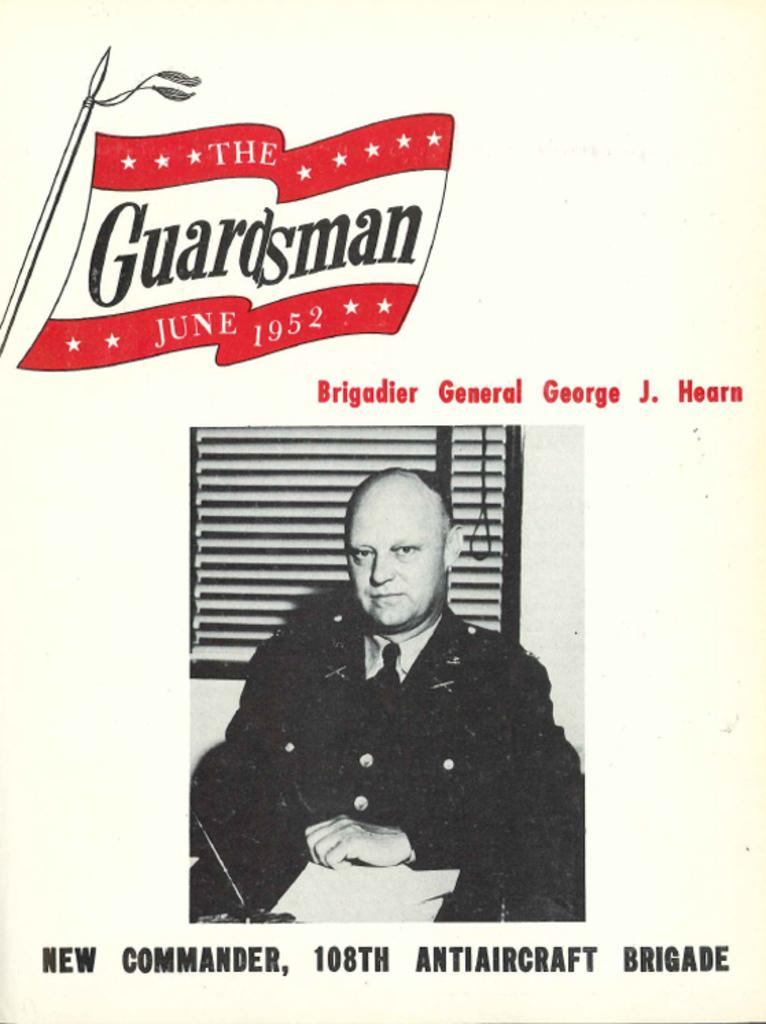What type of editing has been done to the image? The image is edited. What can be seen in the edited image? There is an image of a person in the edited image. Are there any words or phrases written on the edited image? Yes, there is text written on the edited image. What arithmetic problem is the person solving in the edited image? There is no arithmetic problem visible in the edited image. How does the person's daughter feel about the edited image? The edited image does not show the person's daughter, so it is impossible to determine her feelings about the image. 